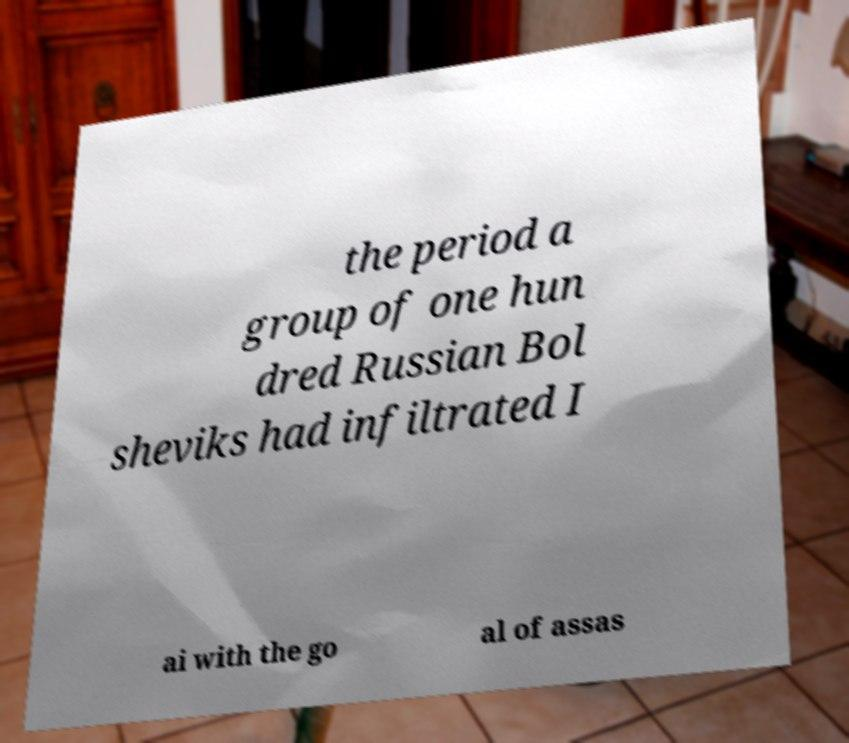What messages or text are displayed in this image? I need them in a readable, typed format. the period a group of one hun dred Russian Bol sheviks had infiltrated I ai with the go al of assas 